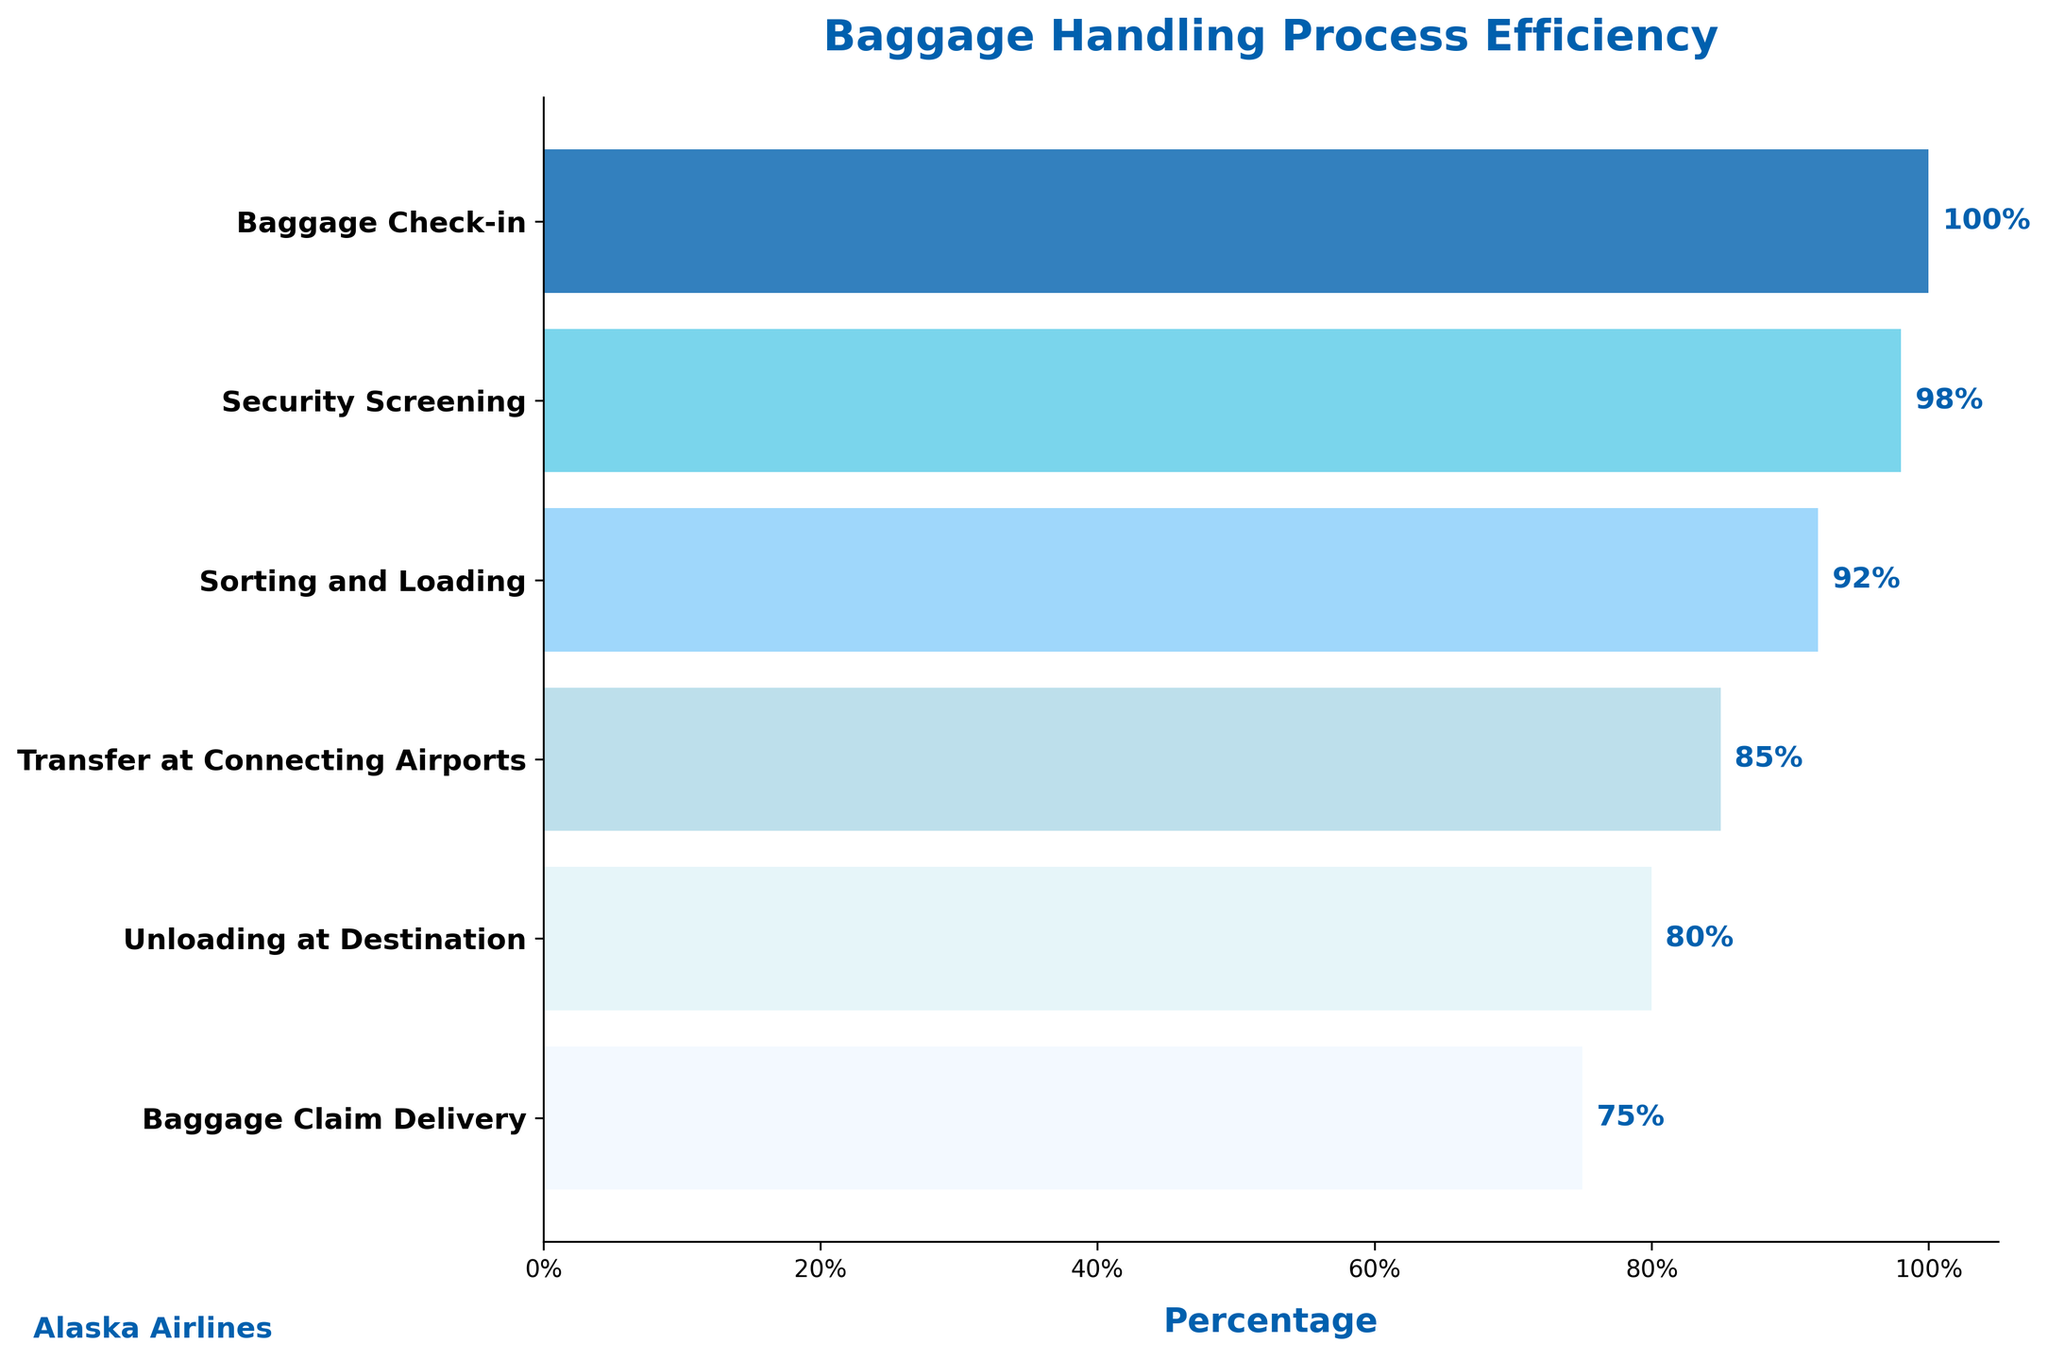Which stage has the lowest efficiency percentage? The stage with the lowest percentage on the funnel chart is the last bar, which is "Baggage Claim Delivery" at 75%.
Answer: Baggage Claim Delivery What is the percentage difference between 'Baggage Check-in' and 'Baggage Claim Delivery'? The percentage for 'Baggage Check-in' is 100%, and for 'Baggage Claim Delivery' is 75%. The difference is 100% - 75% = 25%.
Answer: 25% Which stage has a higher efficiency percentage, 'Security Screening' or 'Sorting and Loading'? 'Security Screening' has a percentage of 98%, and 'Sorting and Loading' has a percentage of 92%. 98% is higher than 92%.
Answer: Security Screening What percentage of luggage makes it through both 'Sorting and Loading' and 'Baggage Claim Delivery'? 'Sorting and Loading' has 92%, and 'Baggage Claim Delivery' has 75%. Both percentages are indicated directly for these stages.
Answer: 75% How many stages are shown in the figure? Count the number of horizontal bars (or categories) present on the y-axis of the funnel chart. There are 6 stages shown.
Answer: 6 What is the title of the funnel chart? The title is displayed at the top of the funnel chart. It reads "Baggage Handling Process Efficiency".
Answer: Baggage Handling Process Efficiency If 1000 bags are checked in, how many make it through 'Transfer at Connecting Airports'? First, note that 'Transfer at Connecting Airports' has an efficiency of 85%. If 1000 bags are checked in, then 1000 * 0.85 = 850 bags make it through this stage.
Answer: 850 By how many percentage points does the efficiency drop from 'Sorting and Loading' to 'Unloading at Destination'? 'Sorting and Loading' has 92%, and 'Unloading at Destination' has 80%. The drop is 92% - 80% = 12 percentage points.
Answer: 12 Which stages have a higher efficiency than 'Unloading at Destination'? Compare percentages higher than 80%. These include 'Baggage Check-in' (100%), 'Security Screening' (98%), 'Sorting and Loading' (92%), and 'Transfer at Connecting Airports' (85%).
Answer: Baggage Check-in, Security Screening, Sorting and Loading, Transfer at Connecting Airports What color represents the 'Baggage Check-in' stage? Identify the color of the first bar in the funnel chart which represents 'Baggage Check-in'. The color is a specific shade of blue.
Answer: Blue 